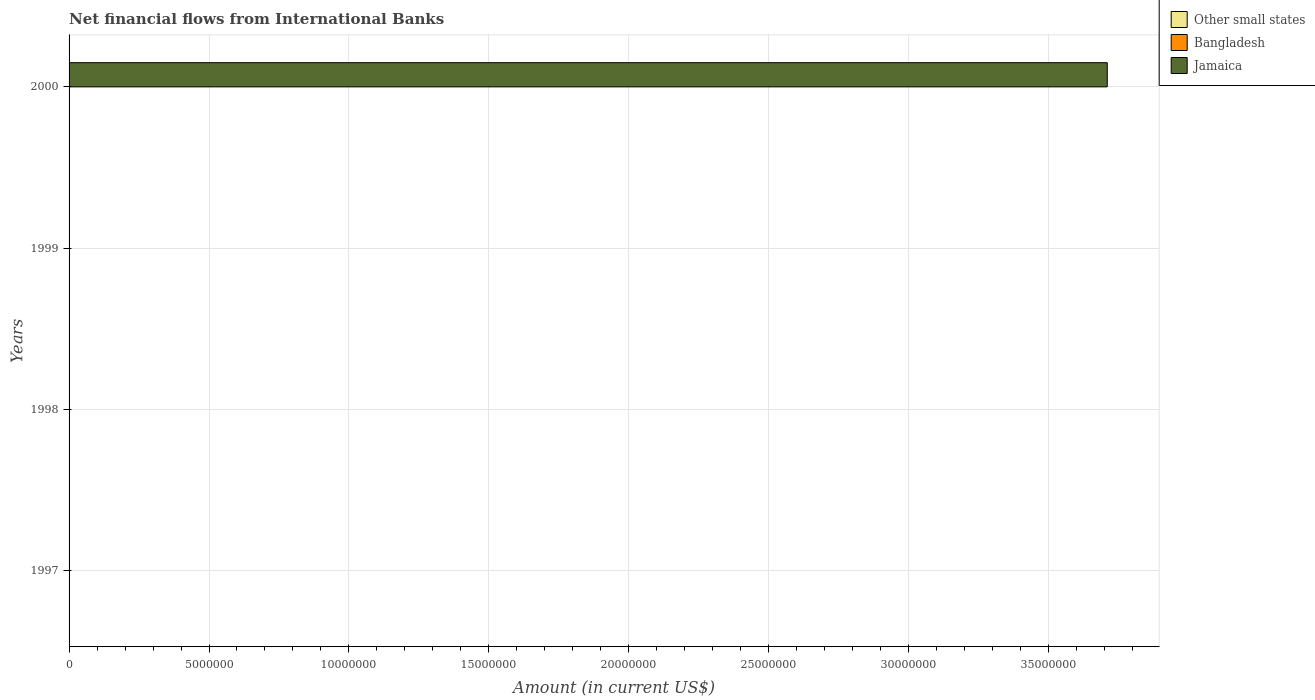Are the number of bars on each tick of the Y-axis equal?
Your answer should be very brief. No. What is the label of the 2nd group of bars from the top?
Keep it short and to the point. 1999. Across all years, what is the maximum net financial aid flows in Jamaica?
Give a very brief answer. 3.71e+07. What is the total net financial aid flows in Other small states in the graph?
Offer a very short reply. 0. What is the difference between the net financial aid flows in Other small states in 2000 and the net financial aid flows in Jamaica in 1999?
Your response must be concise. 0. What is the average net financial aid flows in Other small states per year?
Your answer should be very brief. 0. What is the difference between the highest and the lowest net financial aid flows in Jamaica?
Offer a terse response. 3.71e+07. How many bars are there?
Give a very brief answer. 1. Are all the bars in the graph horizontal?
Provide a succinct answer. Yes. What is the difference between two consecutive major ticks on the X-axis?
Provide a short and direct response. 5.00e+06. Are the values on the major ticks of X-axis written in scientific E-notation?
Offer a terse response. No. How are the legend labels stacked?
Make the answer very short. Vertical. What is the title of the graph?
Keep it short and to the point. Net financial flows from International Banks. Does "Hong Kong" appear as one of the legend labels in the graph?
Provide a short and direct response. No. What is the label or title of the X-axis?
Your answer should be very brief. Amount (in current US$). What is the Amount (in current US$) in Other small states in 1997?
Give a very brief answer. 0. What is the Amount (in current US$) of Bangladesh in 1997?
Your answer should be very brief. 0. What is the Amount (in current US$) in Jamaica in 1997?
Keep it short and to the point. 0. What is the Amount (in current US$) in Other small states in 1998?
Ensure brevity in your answer.  0. What is the Amount (in current US$) in Other small states in 1999?
Offer a very short reply. 0. What is the Amount (in current US$) in Jamaica in 1999?
Make the answer very short. 0. What is the Amount (in current US$) of Bangladesh in 2000?
Offer a terse response. 0. What is the Amount (in current US$) in Jamaica in 2000?
Your answer should be compact. 3.71e+07. Across all years, what is the maximum Amount (in current US$) of Jamaica?
Provide a succinct answer. 3.71e+07. Across all years, what is the minimum Amount (in current US$) in Jamaica?
Ensure brevity in your answer.  0. What is the total Amount (in current US$) of Other small states in the graph?
Offer a very short reply. 0. What is the total Amount (in current US$) in Jamaica in the graph?
Your response must be concise. 3.71e+07. What is the average Amount (in current US$) in Other small states per year?
Give a very brief answer. 0. What is the average Amount (in current US$) of Jamaica per year?
Provide a short and direct response. 9.27e+06. What is the difference between the highest and the lowest Amount (in current US$) of Jamaica?
Your answer should be compact. 3.71e+07. 